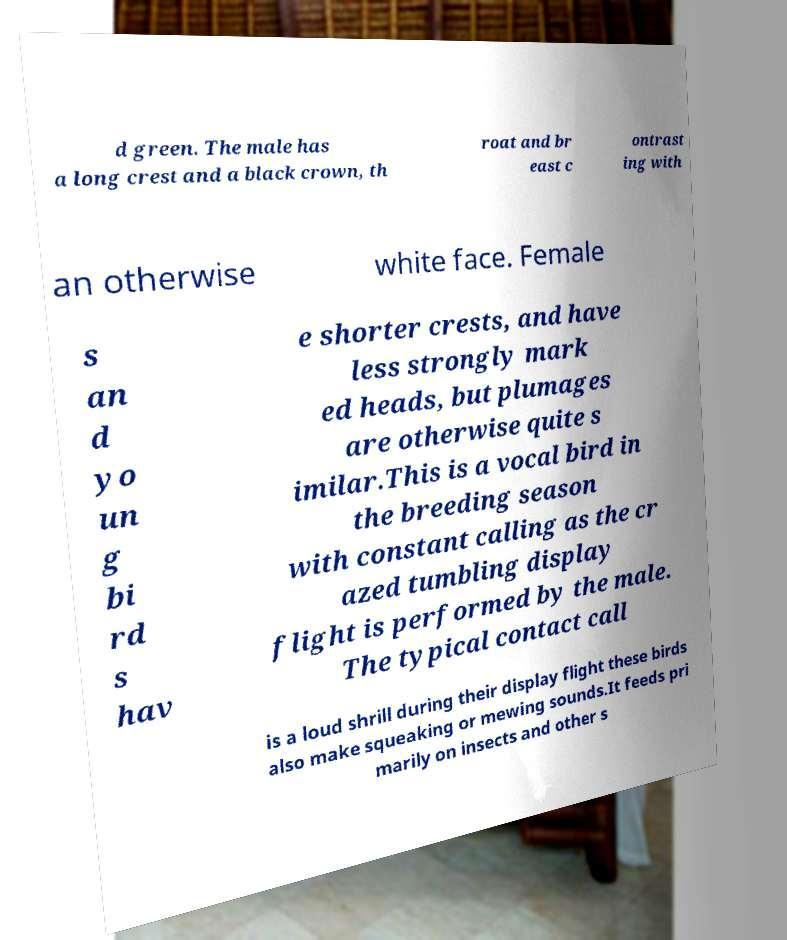I need the written content from this picture converted into text. Can you do that? d green. The male has a long crest and a black crown, th roat and br east c ontrast ing with an otherwise white face. Female s an d yo un g bi rd s hav e shorter crests, and have less strongly mark ed heads, but plumages are otherwise quite s imilar.This is a vocal bird in the breeding season with constant calling as the cr azed tumbling display flight is performed by the male. The typical contact call is a loud shrill during their display flight these birds also make squeaking or mewing sounds.It feeds pri marily on insects and other s 